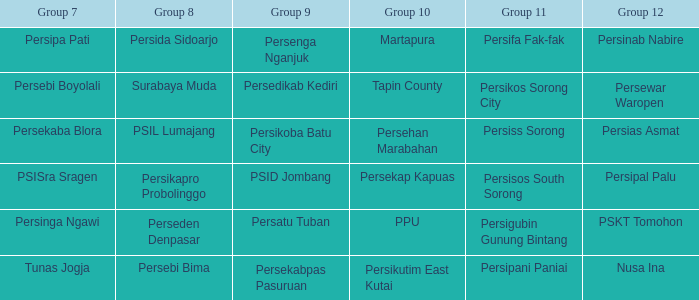Help me parse the entirety of this table. {'header': ['Group 7', 'Group 8', 'Group 9', 'Group 10', 'Group 11', 'Group 12'], 'rows': [['Persipa Pati', 'Persida Sidoarjo', 'Persenga Nganjuk', 'Martapura', 'Persifa Fak-fak', 'Persinab Nabire'], ['Persebi Boyolali', 'Surabaya Muda', 'Persedikab Kediri', 'Tapin County', 'Persikos Sorong City', 'Persewar Waropen'], ['Persekaba Blora', 'PSIL Lumajang', 'Persikoba Batu City', 'Persehan Marabahan', 'Persiss Sorong', 'Persias Asmat'], ['PSISra Sragen', 'Persikapro Probolinggo', 'PSID Jombang', 'Persekap Kapuas', 'Persisos South Sorong', 'Persipal Palu'], ['Persinga Ngawi', 'Perseden Denpasar', 'Persatu Tuban', 'PPU', 'Persigubin Gunung Bintang', 'PSKT Tomohon'], ['Tunas Jogja', 'Persebi Bima', 'Persekabpas Pasuruan', 'Persikutim East Kutai', 'Persipani Paniai', 'Nusa Ina']]} Did nusa ina play only one time during the time group 7 played? 1.0. 